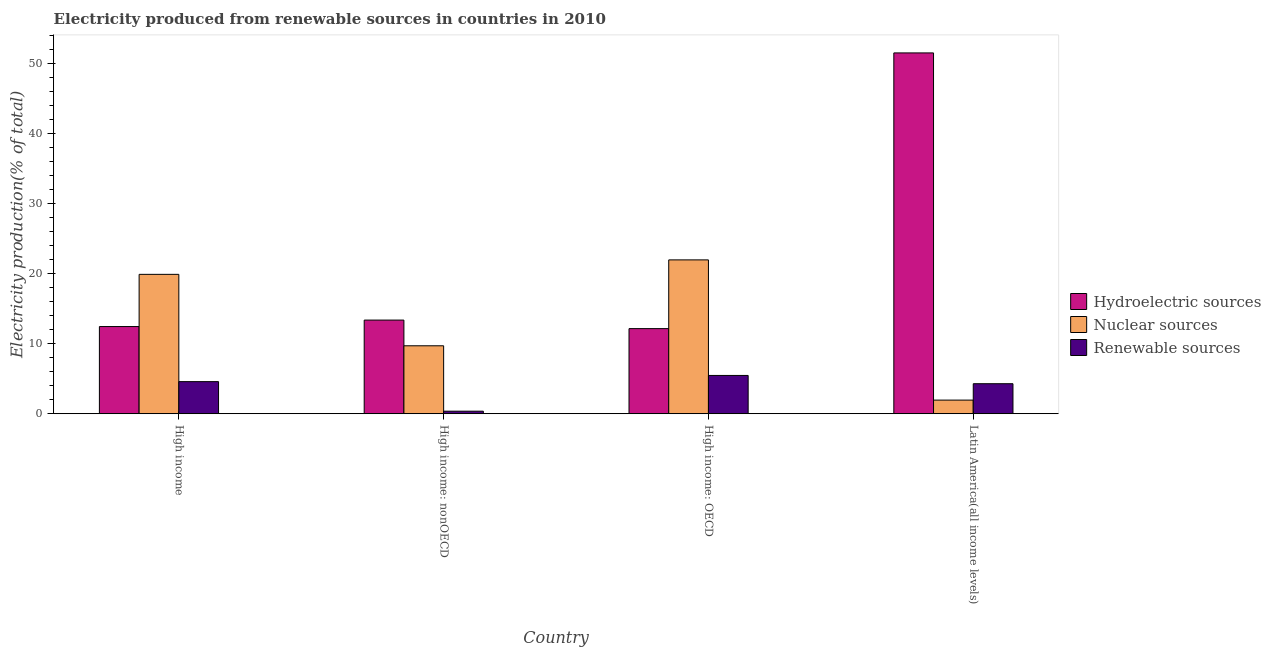How many different coloured bars are there?
Your response must be concise. 3. Are the number of bars on each tick of the X-axis equal?
Ensure brevity in your answer.  Yes. How many bars are there on the 4th tick from the right?
Ensure brevity in your answer.  3. What is the label of the 4th group of bars from the left?
Provide a short and direct response. Latin America(all income levels). In how many cases, is the number of bars for a given country not equal to the number of legend labels?
Offer a terse response. 0. What is the percentage of electricity produced by hydroelectric sources in High income: OECD?
Keep it short and to the point. 12.17. Across all countries, what is the maximum percentage of electricity produced by renewable sources?
Offer a terse response. 5.47. Across all countries, what is the minimum percentage of electricity produced by nuclear sources?
Offer a very short reply. 1.95. In which country was the percentage of electricity produced by renewable sources maximum?
Make the answer very short. High income: OECD. In which country was the percentage of electricity produced by renewable sources minimum?
Provide a short and direct response. High income: nonOECD. What is the total percentage of electricity produced by hydroelectric sources in the graph?
Your answer should be very brief. 89.6. What is the difference between the percentage of electricity produced by renewable sources in High income and that in High income: OECD?
Give a very brief answer. -0.88. What is the difference between the percentage of electricity produced by renewable sources in High income: OECD and the percentage of electricity produced by nuclear sources in Latin America(all income levels)?
Provide a short and direct response. 3.52. What is the average percentage of electricity produced by renewable sources per country?
Keep it short and to the point. 3.68. What is the difference between the percentage of electricity produced by renewable sources and percentage of electricity produced by hydroelectric sources in High income: OECD?
Provide a short and direct response. -6.69. In how many countries, is the percentage of electricity produced by nuclear sources greater than 38 %?
Ensure brevity in your answer.  0. What is the ratio of the percentage of electricity produced by renewable sources in High income to that in High income: nonOECD?
Offer a very short reply. 12.51. Is the percentage of electricity produced by hydroelectric sources in High income: nonOECD less than that in Latin America(all income levels)?
Your answer should be compact. Yes. Is the difference between the percentage of electricity produced by hydroelectric sources in High income: OECD and Latin America(all income levels) greater than the difference between the percentage of electricity produced by renewable sources in High income: OECD and Latin America(all income levels)?
Provide a succinct answer. No. What is the difference between the highest and the second highest percentage of electricity produced by nuclear sources?
Provide a succinct answer. 2.07. What is the difference between the highest and the lowest percentage of electricity produced by nuclear sources?
Offer a terse response. 20.04. What does the 1st bar from the left in Latin America(all income levels) represents?
Your response must be concise. Hydroelectric sources. What does the 3rd bar from the right in Latin America(all income levels) represents?
Give a very brief answer. Hydroelectric sources. Are all the bars in the graph horizontal?
Provide a succinct answer. No. Where does the legend appear in the graph?
Keep it short and to the point. Center right. How many legend labels are there?
Give a very brief answer. 3. What is the title of the graph?
Your response must be concise. Electricity produced from renewable sources in countries in 2010. Does "Ores and metals" appear as one of the legend labels in the graph?
Give a very brief answer. No. What is the label or title of the X-axis?
Provide a short and direct response. Country. What is the label or title of the Y-axis?
Your answer should be very brief. Electricity production(% of total). What is the Electricity production(% of total) of Hydroelectric sources in High income?
Your response must be concise. 12.46. What is the Electricity production(% of total) in Nuclear sources in High income?
Your answer should be compact. 19.93. What is the Electricity production(% of total) of Renewable sources in High income?
Provide a succinct answer. 4.59. What is the Electricity production(% of total) of Hydroelectric sources in High income: nonOECD?
Make the answer very short. 13.39. What is the Electricity production(% of total) of Nuclear sources in High income: nonOECD?
Provide a short and direct response. 9.71. What is the Electricity production(% of total) in Renewable sources in High income: nonOECD?
Your response must be concise. 0.37. What is the Electricity production(% of total) in Hydroelectric sources in High income: OECD?
Offer a terse response. 12.17. What is the Electricity production(% of total) in Nuclear sources in High income: OECD?
Provide a succinct answer. 21.99. What is the Electricity production(% of total) in Renewable sources in High income: OECD?
Your answer should be compact. 5.47. What is the Electricity production(% of total) of Hydroelectric sources in Latin America(all income levels)?
Your response must be concise. 51.58. What is the Electricity production(% of total) in Nuclear sources in Latin America(all income levels)?
Offer a terse response. 1.95. What is the Electricity production(% of total) of Renewable sources in Latin America(all income levels)?
Your response must be concise. 4.29. Across all countries, what is the maximum Electricity production(% of total) in Hydroelectric sources?
Ensure brevity in your answer.  51.58. Across all countries, what is the maximum Electricity production(% of total) of Nuclear sources?
Keep it short and to the point. 21.99. Across all countries, what is the maximum Electricity production(% of total) in Renewable sources?
Your answer should be very brief. 5.47. Across all countries, what is the minimum Electricity production(% of total) in Hydroelectric sources?
Offer a terse response. 12.17. Across all countries, what is the minimum Electricity production(% of total) of Nuclear sources?
Provide a short and direct response. 1.95. Across all countries, what is the minimum Electricity production(% of total) of Renewable sources?
Your response must be concise. 0.37. What is the total Electricity production(% of total) in Hydroelectric sources in the graph?
Offer a terse response. 89.6. What is the total Electricity production(% of total) of Nuclear sources in the graph?
Offer a terse response. 53.58. What is the total Electricity production(% of total) in Renewable sources in the graph?
Your answer should be compact. 14.72. What is the difference between the Electricity production(% of total) in Hydroelectric sources in High income and that in High income: nonOECD?
Your answer should be very brief. -0.92. What is the difference between the Electricity production(% of total) of Nuclear sources in High income and that in High income: nonOECD?
Your answer should be very brief. 10.21. What is the difference between the Electricity production(% of total) of Renewable sources in High income and that in High income: nonOECD?
Your answer should be compact. 4.22. What is the difference between the Electricity production(% of total) of Hydroelectric sources in High income and that in High income: OECD?
Provide a short and direct response. 0.3. What is the difference between the Electricity production(% of total) in Nuclear sources in High income and that in High income: OECD?
Offer a very short reply. -2.07. What is the difference between the Electricity production(% of total) of Renewable sources in High income and that in High income: OECD?
Offer a terse response. -0.88. What is the difference between the Electricity production(% of total) of Hydroelectric sources in High income and that in Latin America(all income levels)?
Keep it short and to the point. -39.12. What is the difference between the Electricity production(% of total) of Nuclear sources in High income and that in Latin America(all income levels)?
Offer a very short reply. 17.98. What is the difference between the Electricity production(% of total) of Renewable sources in High income and that in Latin America(all income levels)?
Your answer should be compact. 0.3. What is the difference between the Electricity production(% of total) of Hydroelectric sources in High income: nonOECD and that in High income: OECD?
Ensure brevity in your answer.  1.22. What is the difference between the Electricity production(% of total) in Nuclear sources in High income: nonOECD and that in High income: OECD?
Your answer should be compact. -12.28. What is the difference between the Electricity production(% of total) of Renewable sources in High income: nonOECD and that in High income: OECD?
Your answer should be very brief. -5.11. What is the difference between the Electricity production(% of total) of Hydroelectric sources in High income: nonOECD and that in Latin America(all income levels)?
Provide a succinct answer. -38.19. What is the difference between the Electricity production(% of total) of Nuclear sources in High income: nonOECD and that in Latin America(all income levels)?
Provide a succinct answer. 7.76. What is the difference between the Electricity production(% of total) in Renewable sources in High income: nonOECD and that in Latin America(all income levels)?
Your answer should be very brief. -3.93. What is the difference between the Electricity production(% of total) of Hydroelectric sources in High income: OECD and that in Latin America(all income levels)?
Your answer should be compact. -39.41. What is the difference between the Electricity production(% of total) in Nuclear sources in High income: OECD and that in Latin America(all income levels)?
Keep it short and to the point. 20.04. What is the difference between the Electricity production(% of total) of Renewable sources in High income: OECD and that in Latin America(all income levels)?
Ensure brevity in your answer.  1.18. What is the difference between the Electricity production(% of total) of Hydroelectric sources in High income and the Electricity production(% of total) of Nuclear sources in High income: nonOECD?
Your answer should be very brief. 2.75. What is the difference between the Electricity production(% of total) in Hydroelectric sources in High income and the Electricity production(% of total) in Renewable sources in High income: nonOECD?
Ensure brevity in your answer.  12.1. What is the difference between the Electricity production(% of total) in Nuclear sources in High income and the Electricity production(% of total) in Renewable sources in High income: nonOECD?
Provide a succinct answer. 19.56. What is the difference between the Electricity production(% of total) of Hydroelectric sources in High income and the Electricity production(% of total) of Nuclear sources in High income: OECD?
Provide a short and direct response. -9.53. What is the difference between the Electricity production(% of total) of Hydroelectric sources in High income and the Electricity production(% of total) of Renewable sources in High income: OECD?
Offer a terse response. 6.99. What is the difference between the Electricity production(% of total) in Nuclear sources in High income and the Electricity production(% of total) in Renewable sources in High income: OECD?
Your answer should be compact. 14.45. What is the difference between the Electricity production(% of total) in Hydroelectric sources in High income and the Electricity production(% of total) in Nuclear sources in Latin America(all income levels)?
Your answer should be very brief. 10.51. What is the difference between the Electricity production(% of total) in Hydroelectric sources in High income and the Electricity production(% of total) in Renewable sources in Latin America(all income levels)?
Ensure brevity in your answer.  8.17. What is the difference between the Electricity production(% of total) of Nuclear sources in High income and the Electricity production(% of total) of Renewable sources in Latin America(all income levels)?
Keep it short and to the point. 15.63. What is the difference between the Electricity production(% of total) in Hydroelectric sources in High income: nonOECD and the Electricity production(% of total) in Nuclear sources in High income: OECD?
Your answer should be very brief. -8.61. What is the difference between the Electricity production(% of total) in Hydroelectric sources in High income: nonOECD and the Electricity production(% of total) in Renewable sources in High income: OECD?
Keep it short and to the point. 7.91. What is the difference between the Electricity production(% of total) in Nuclear sources in High income: nonOECD and the Electricity production(% of total) in Renewable sources in High income: OECD?
Offer a terse response. 4.24. What is the difference between the Electricity production(% of total) of Hydroelectric sources in High income: nonOECD and the Electricity production(% of total) of Nuclear sources in Latin America(all income levels)?
Make the answer very short. 11.44. What is the difference between the Electricity production(% of total) of Hydroelectric sources in High income: nonOECD and the Electricity production(% of total) of Renewable sources in Latin America(all income levels)?
Offer a very short reply. 9.09. What is the difference between the Electricity production(% of total) in Nuclear sources in High income: nonOECD and the Electricity production(% of total) in Renewable sources in Latin America(all income levels)?
Offer a terse response. 5.42. What is the difference between the Electricity production(% of total) of Hydroelectric sources in High income: OECD and the Electricity production(% of total) of Nuclear sources in Latin America(all income levels)?
Your response must be concise. 10.22. What is the difference between the Electricity production(% of total) in Hydroelectric sources in High income: OECD and the Electricity production(% of total) in Renewable sources in Latin America(all income levels)?
Make the answer very short. 7.87. What is the difference between the Electricity production(% of total) in Nuclear sources in High income: OECD and the Electricity production(% of total) in Renewable sources in Latin America(all income levels)?
Give a very brief answer. 17.7. What is the average Electricity production(% of total) of Hydroelectric sources per country?
Make the answer very short. 22.4. What is the average Electricity production(% of total) of Nuclear sources per country?
Provide a short and direct response. 13.4. What is the average Electricity production(% of total) in Renewable sources per country?
Provide a short and direct response. 3.68. What is the difference between the Electricity production(% of total) in Hydroelectric sources and Electricity production(% of total) in Nuclear sources in High income?
Your answer should be very brief. -7.46. What is the difference between the Electricity production(% of total) of Hydroelectric sources and Electricity production(% of total) of Renewable sources in High income?
Your response must be concise. 7.87. What is the difference between the Electricity production(% of total) of Nuclear sources and Electricity production(% of total) of Renewable sources in High income?
Make the answer very short. 15.34. What is the difference between the Electricity production(% of total) of Hydroelectric sources and Electricity production(% of total) of Nuclear sources in High income: nonOECD?
Provide a succinct answer. 3.67. What is the difference between the Electricity production(% of total) of Hydroelectric sources and Electricity production(% of total) of Renewable sources in High income: nonOECD?
Offer a terse response. 13.02. What is the difference between the Electricity production(% of total) in Nuclear sources and Electricity production(% of total) in Renewable sources in High income: nonOECD?
Ensure brevity in your answer.  9.35. What is the difference between the Electricity production(% of total) of Hydroelectric sources and Electricity production(% of total) of Nuclear sources in High income: OECD?
Provide a short and direct response. -9.83. What is the difference between the Electricity production(% of total) of Hydroelectric sources and Electricity production(% of total) of Renewable sources in High income: OECD?
Give a very brief answer. 6.69. What is the difference between the Electricity production(% of total) of Nuclear sources and Electricity production(% of total) of Renewable sources in High income: OECD?
Keep it short and to the point. 16.52. What is the difference between the Electricity production(% of total) in Hydroelectric sources and Electricity production(% of total) in Nuclear sources in Latin America(all income levels)?
Keep it short and to the point. 49.63. What is the difference between the Electricity production(% of total) of Hydroelectric sources and Electricity production(% of total) of Renewable sources in Latin America(all income levels)?
Keep it short and to the point. 47.29. What is the difference between the Electricity production(% of total) in Nuclear sources and Electricity production(% of total) in Renewable sources in Latin America(all income levels)?
Your response must be concise. -2.34. What is the ratio of the Electricity production(% of total) in Nuclear sources in High income to that in High income: nonOECD?
Ensure brevity in your answer.  2.05. What is the ratio of the Electricity production(% of total) of Renewable sources in High income to that in High income: nonOECD?
Make the answer very short. 12.51. What is the ratio of the Electricity production(% of total) of Hydroelectric sources in High income to that in High income: OECD?
Your response must be concise. 1.02. What is the ratio of the Electricity production(% of total) of Nuclear sources in High income to that in High income: OECD?
Your answer should be compact. 0.91. What is the ratio of the Electricity production(% of total) of Renewable sources in High income to that in High income: OECD?
Keep it short and to the point. 0.84. What is the ratio of the Electricity production(% of total) in Hydroelectric sources in High income to that in Latin America(all income levels)?
Provide a short and direct response. 0.24. What is the ratio of the Electricity production(% of total) in Nuclear sources in High income to that in Latin America(all income levels)?
Offer a very short reply. 10.22. What is the ratio of the Electricity production(% of total) of Renewable sources in High income to that in Latin America(all income levels)?
Ensure brevity in your answer.  1.07. What is the ratio of the Electricity production(% of total) in Hydroelectric sources in High income: nonOECD to that in High income: OECD?
Provide a short and direct response. 1.1. What is the ratio of the Electricity production(% of total) of Nuclear sources in High income: nonOECD to that in High income: OECD?
Provide a short and direct response. 0.44. What is the ratio of the Electricity production(% of total) of Renewable sources in High income: nonOECD to that in High income: OECD?
Keep it short and to the point. 0.07. What is the ratio of the Electricity production(% of total) in Hydroelectric sources in High income: nonOECD to that in Latin America(all income levels)?
Your answer should be very brief. 0.26. What is the ratio of the Electricity production(% of total) of Nuclear sources in High income: nonOECD to that in Latin America(all income levels)?
Ensure brevity in your answer.  4.98. What is the ratio of the Electricity production(% of total) of Renewable sources in High income: nonOECD to that in Latin America(all income levels)?
Provide a short and direct response. 0.09. What is the ratio of the Electricity production(% of total) in Hydroelectric sources in High income: OECD to that in Latin America(all income levels)?
Offer a terse response. 0.24. What is the ratio of the Electricity production(% of total) of Nuclear sources in High income: OECD to that in Latin America(all income levels)?
Offer a very short reply. 11.28. What is the ratio of the Electricity production(% of total) of Renewable sources in High income: OECD to that in Latin America(all income levels)?
Your response must be concise. 1.27. What is the difference between the highest and the second highest Electricity production(% of total) in Hydroelectric sources?
Provide a succinct answer. 38.19. What is the difference between the highest and the second highest Electricity production(% of total) in Nuclear sources?
Provide a short and direct response. 2.07. What is the difference between the highest and the second highest Electricity production(% of total) of Renewable sources?
Provide a succinct answer. 0.88. What is the difference between the highest and the lowest Electricity production(% of total) of Hydroelectric sources?
Your answer should be compact. 39.41. What is the difference between the highest and the lowest Electricity production(% of total) of Nuclear sources?
Your answer should be very brief. 20.04. What is the difference between the highest and the lowest Electricity production(% of total) in Renewable sources?
Your answer should be compact. 5.11. 